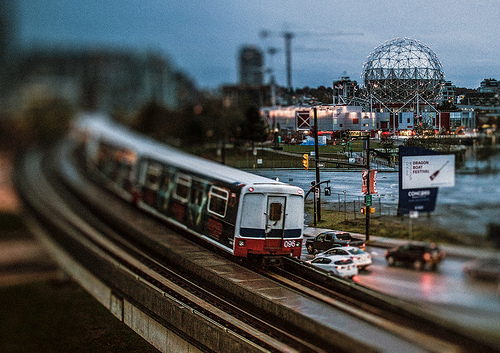<image>
Can you confirm if the train is to the left of the advertisement board? Yes. From this viewpoint, the train is positioned to the left side relative to the advertisement board. 